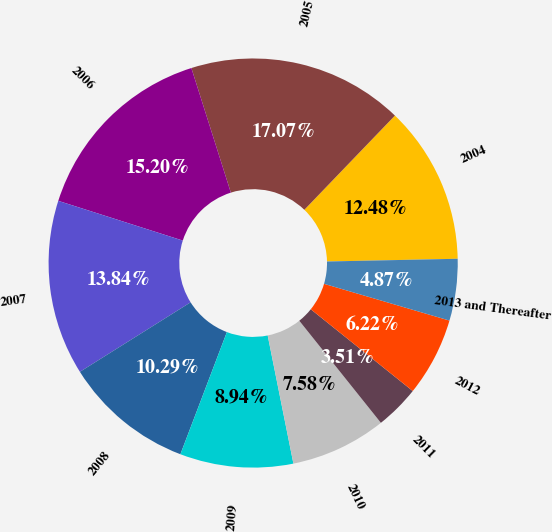Convert chart. <chart><loc_0><loc_0><loc_500><loc_500><pie_chart><fcel>2004<fcel>2005<fcel>2006<fcel>2007<fcel>2008<fcel>2009<fcel>2010<fcel>2011<fcel>2012<fcel>2013 and Thereafter<nl><fcel>12.48%<fcel>17.07%<fcel>15.2%<fcel>13.84%<fcel>10.29%<fcel>8.94%<fcel>7.58%<fcel>3.51%<fcel>6.22%<fcel>4.87%<nl></chart> 